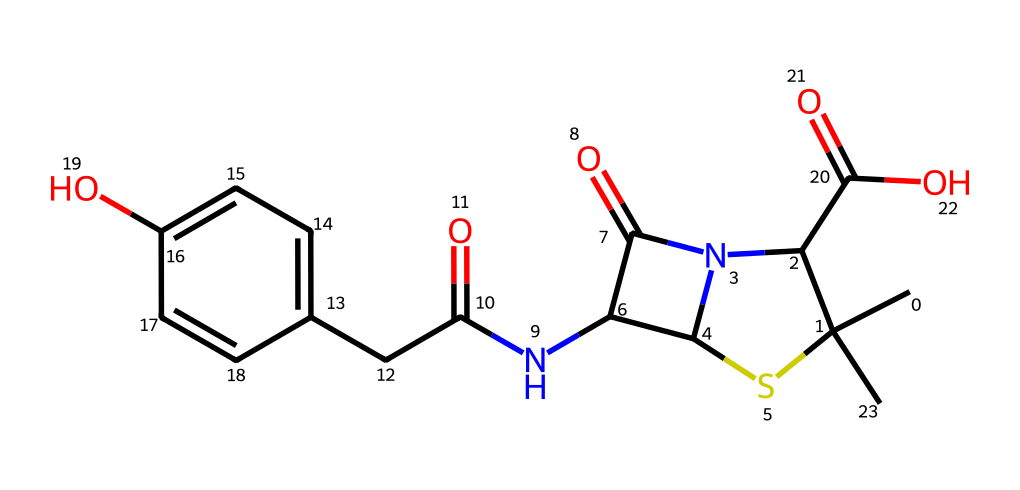What is the molecular formula of this compound? To find the molecular formula, we count the atoms of each element in the SMILES representation. The structure contains 14 carbon (C) atoms, 18 hydrogen (H) atoms, 4 nitrogen (N) atoms, 4 oxygen (O) atoms, and 1 sulfur (S) atom. Therefore, the molecular formula is C14H18N4O4S.
Answer: C14H18N4O4S How many distinct rings are present in this compound? By analyzing the structure derived from the SMILES representation, we can identify the cyclic components. There are two distinct rings: one contains sulfur and nitrogen atoms (a thiazole-like structure), and the second is a phenolic ring. Thus, the total number of distinct rings is 2.
Answer: 2 What type of medicinal compound is indicated by this structure? The presence of multiple nitrogen atoms and a phenolic structure, alongside specific functional groups, typically indicates that this compound is classified as an antibiotic.
Answer: antibiotic What specific functional group can be identified in the chemical structure? Looking at the SMILES, we identify a carboxylic acid group (-COOH) attached to the carbon chain. This is evident from the segment "C(=O)O" within the SMILES, signifying the presence of a -COOH functional group.
Answer: carboxylic acid What is the characteristic element that hints at the antibiotic nature of this compound? The presence of nitrogen atoms is a strong indicator of many antibiotic compounds since nitrogen often appears in the structure of drugs that target bacterial processes. In this structure, there are four nitrogen atoms, which is characteristic of antibiotics.
Answer: nitrogen 